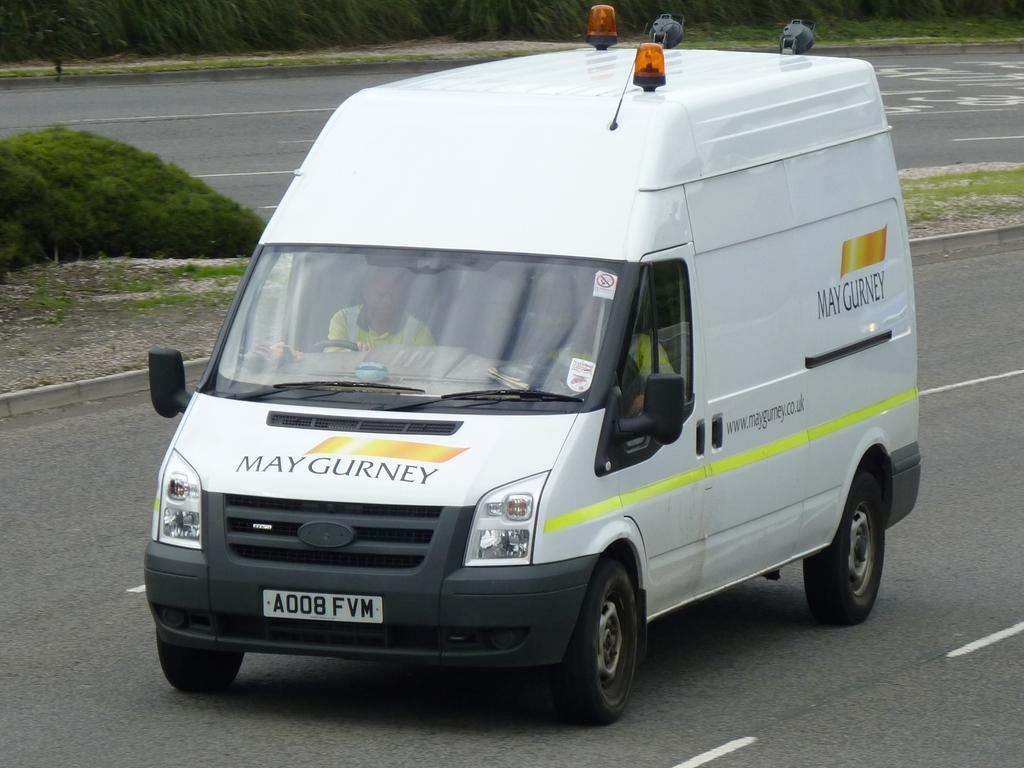What type of vehicle is in the image? There is a white colored van in the image. Where is the van located? The van is on the road. Is there anyone inside the van? Yes, there is a person sitting in the van. What else can be seen in the image besides the van? Plants are present in the image. What time of day is the recess taking place in the image? There is no indication of a recess or any school-related activity in the image. 